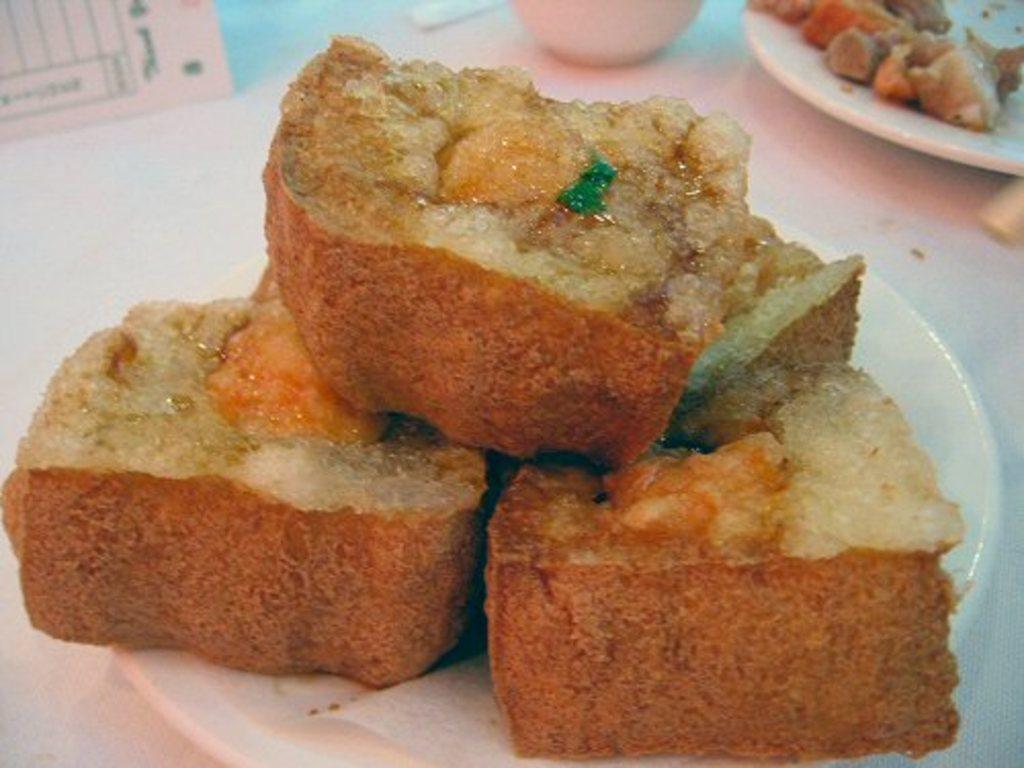In one or two sentences, can you explain what this image depicts? In this image we can see food items on a plate on the platform. At the top we can see objects and food item in a plate on the platform. 